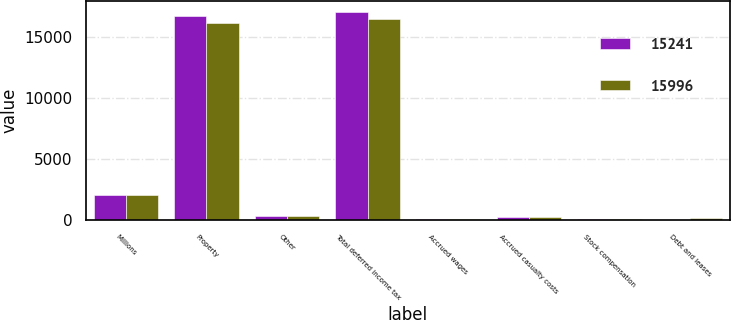Convert chart to OTSL. <chart><loc_0><loc_0><loc_500><loc_500><stacked_bar_chart><ecel><fcel>Millions<fcel>Property<fcel>Other<fcel>Total deferred income tax<fcel>Accrued wages<fcel>Accrued casualty costs<fcel>Stock compensation<fcel>Debt and leases<nl><fcel>15241<fcel>2016<fcel>16687<fcel>346<fcel>17033<fcel>75<fcel>231<fcel>69<fcel>14<nl><fcel>15996<fcel>2015<fcel>16079<fcel>352<fcel>16431<fcel>76<fcel>237<fcel>72<fcel>149<nl></chart> 